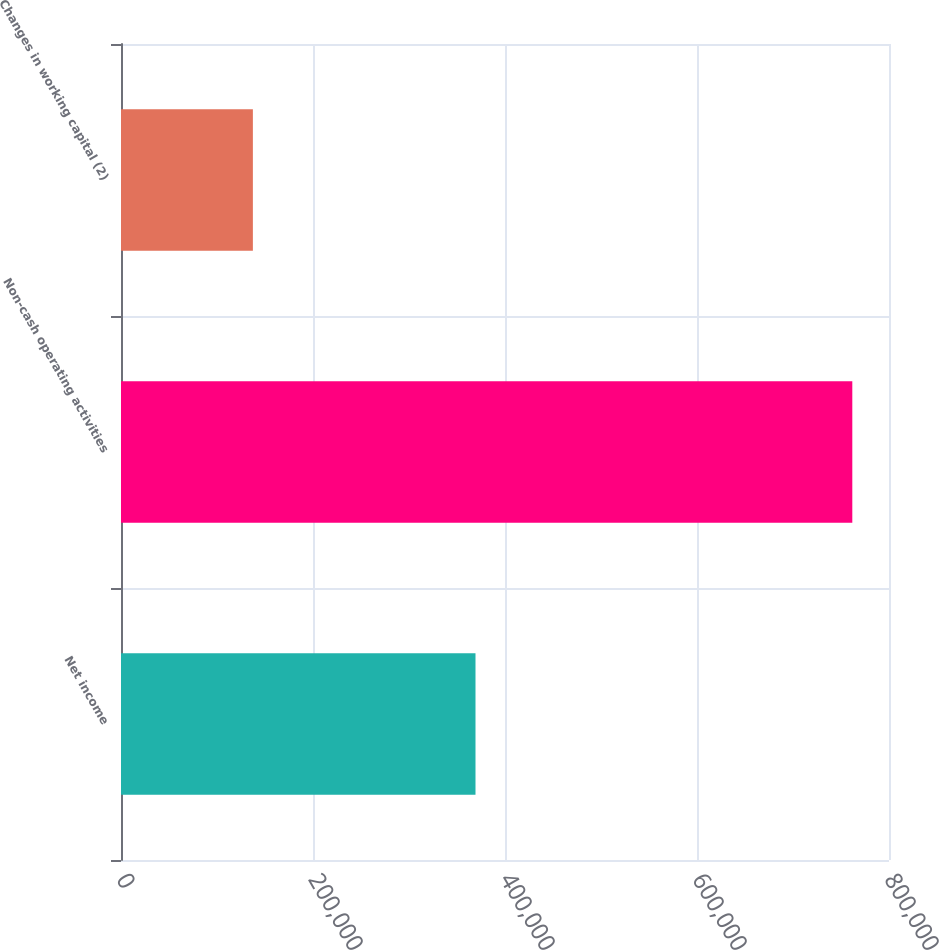<chart> <loc_0><loc_0><loc_500><loc_500><bar_chart><fcel>Net income<fcel>Non-cash operating activities<fcel>Changes in working capital (2)<nl><fcel>369264<fcel>761772<fcel>137374<nl></chart> 